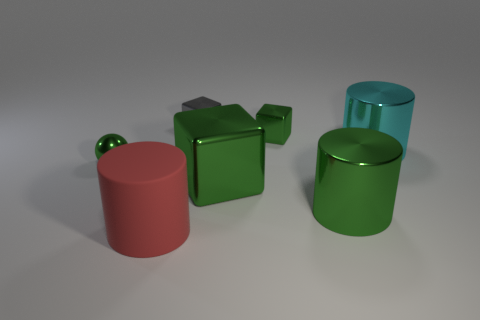Add 2 tiny rubber spheres. How many objects exist? 9 Subtract all spheres. How many objects are left? 6 Add 5 big shiny things. How many big shiny things exist? 8 Subtract 0 cyan balls. How many objects are left? 7 Subtract all large shiny blocks. Subtract all gray cubes. How many objects are left? 5 Add 6 large green cubes. How many large green cubes are left? 7 